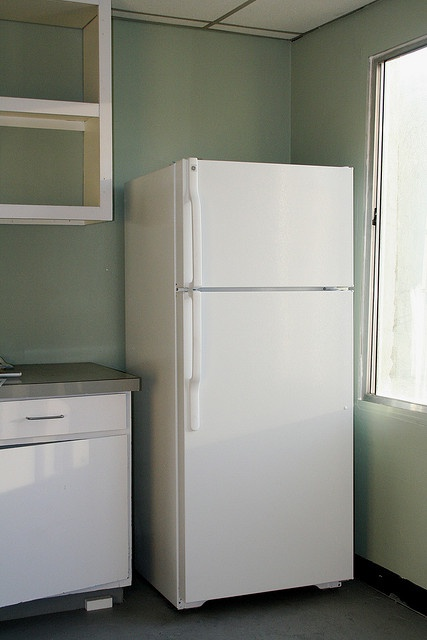Describe the objects in this image and their specific colors. I can see a refrigerator in darkgreen, lightgray, darkgray, and gray tones in this image. 